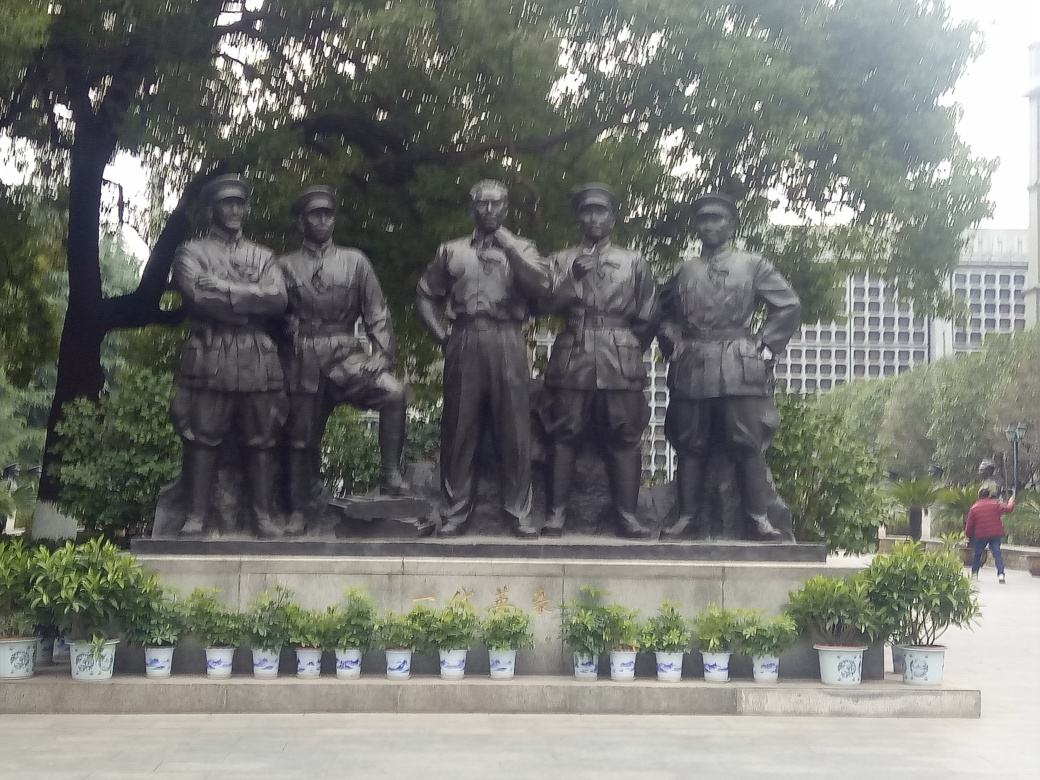Can you tell me about the composition and aesthetics of this statue? Certainly! The statue has a symmetrical composition that draws attention to the central figure, which suggests a leadership role. The aesthetics suggest a formal and dignified portrayal, emphasizing the solemnity and respect typically associated with a military memorial. Are there any notable artistic details? While the details are not discernible from the image, such statues usually feature details like rank insignias, badges, and other elements that denote individual achievements or unit affiliations. These details contribute to the historical accuracy and significance of the monument. 